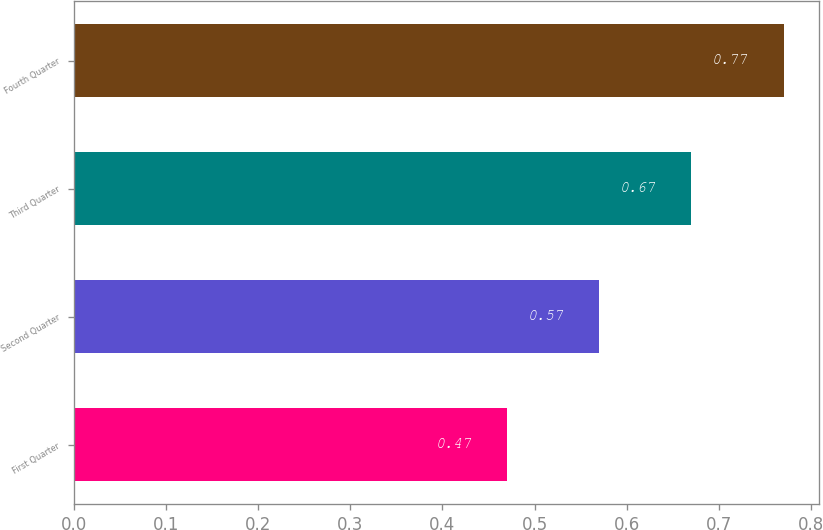Convert chart. <chart><loc_0><loc_0><loc_500><loc_500><bar_chart><fcel>First Quarter<fcel>Second Quarter<fcel>Third Quarter<fcel>Fourth Quarter<nl><fcel>0.47<fcel>0.57<fcel>0.67<fcel>0.77<nl></chart> 